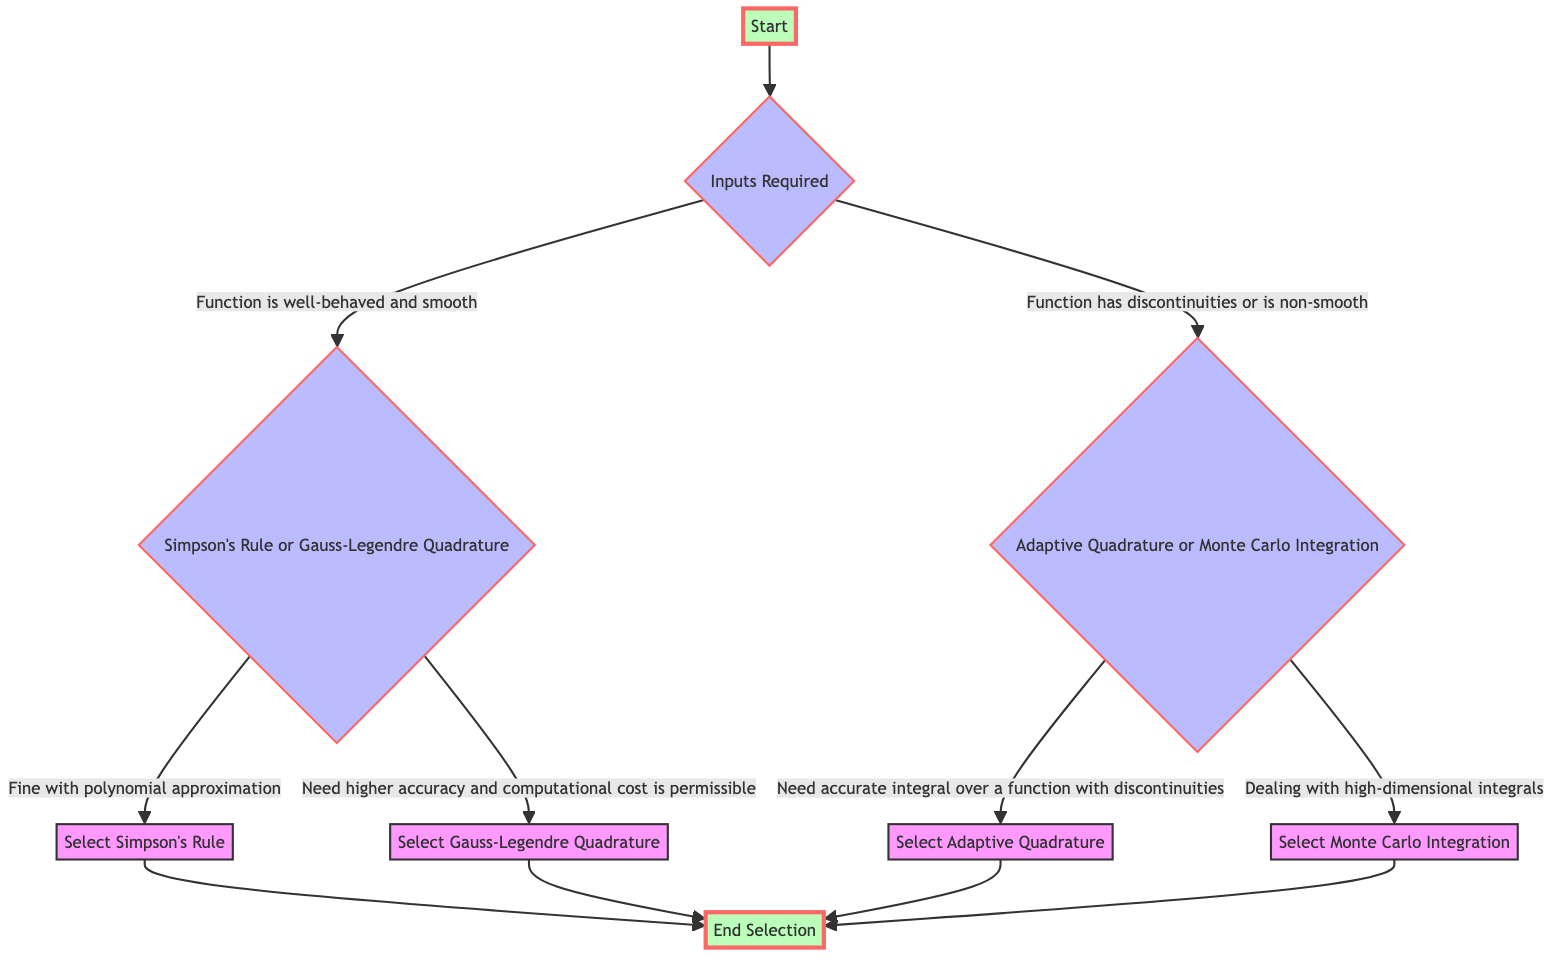What's the first step in the selection process? The first step, as shown in the diagram, is labeled as "Start". This indicates that the selection process begins here.
Answer: Start How many main decision nodes are present in the diagram? The diagram features three main decision nodes: "Inputs Required", "Simpson's Rule or Gauss-Legendre Quadrature", and "Adaptive Quadrature or Monte Carlo Integration". Counting these nodes, we find there are three.
Answer: 3 What action is taken if the function is smooth? If the function is well-behaved and smooth, the next step in the diagram directs to "Simpson's Rule or Gauss-Legendre Quadrature". This is the action suggested for smooth functions.
Answer: Consider Simpson's Rule or Gauss-Legendre Quadrature If the function has discontinuities, which integration method might be selected? If the function has discontinuities or is non-smooth, the next step directs to "Adaptive Quadrature or Monte Carlo Integration", indicating that one of these methods will be considered.
Answer: Consider Adaptive Quadrature or Monte Carlo Integration What is chosen if higher accuracy is needed and computational cost is permissible? In the case where higher accuracy is needed and computational cost is permissible, the diagram suggests selecting "Gauss-Legendre Quadrature" as the appropriate method.
Answer: Select Gauss-Legendre Quadrature Explain what happens at the decision node for "Adaptive Quadrature or Monte Carlo Integration". At this decision node, two actions may follow based on different conditions: if accurate integration over a function with discontinuities is needed, it directs to "Select Adaptive Quadrature", or if dealing with high-dimensional integrals, it directs to "Select Monte Carlo Integration". Hence, the next step depends on the specific scenario encountered.
Answer: Select Adaptive Quadrature or Select Monte Carlo Integration What leads to the end of the selection process? The end of the selection process is reached after selecting any one of the four options: "Select Simpson's Rule", "Select Gauss-Legendre Quadrature", "Select Adaptive Quadrature", or "Select Monte Carlo Integration", which all point to the node labeled "End Selection".
Answer: End Selection What is indicated if the function is polynomial-like? If the function is polynomial-like, as per the diagram, the selection process then suggests "Select Simpson's Rule" as the suitable method, indicating it is appropriate for polynomial approximations.
Answer: Select Simpson's Rule 